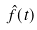Convert formula to latex. <formula><loc_0><loc_0><loc_500><loc_500>\hat { f } ( t )</formula> 